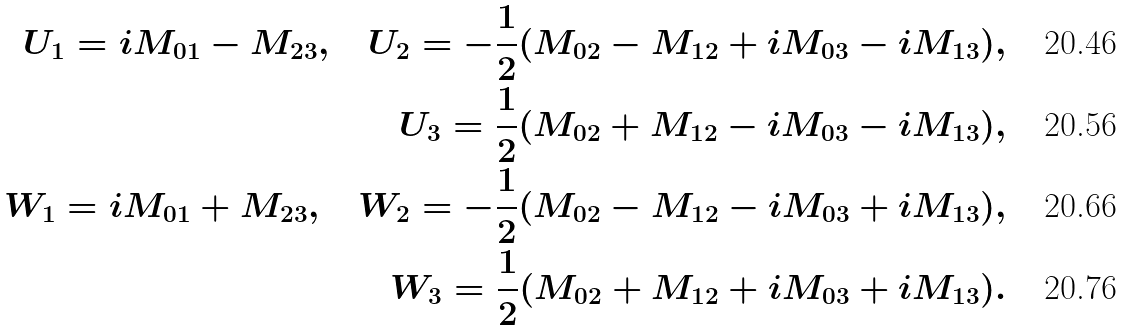Convert formula to latex. <formula><loc_0><loc_0><loc_500><loc_500>U _ { 1 } = i M _ { 0 1 } - M _ { 2 3 } , \quad U _ { 2 } = - \frac { 1 } { 2 } ( M _ { 0 2 } - M _ { 1 2 } + i M _ { 0 3 } - i M _ { 1 3 } ) , \\ U _ { 3 } = \frac { 1 } { 2 } ( M _ { 0 2 } + M _ { 1 2 } - i M _ { 0 3 } - i M _ { 1 3 } ) , \\ W _ { 1 } = i M _ { 0 1 } + M _ { 2 3 } , \quad W _ { 2 } = - \frac { 1 } { 2 } ( M _ { 0 2 } - M _ { 1 2 } - i M _ { 0 3 } + i M _ { 1 3 } ) , \\ W _ { 3 } = \frac { 1 } { 2 } ( M _ { 0 2 } + M _ { 1 2 } + i M _ { 0 3 } + i M _ { 1 3 } ) .</formula> 